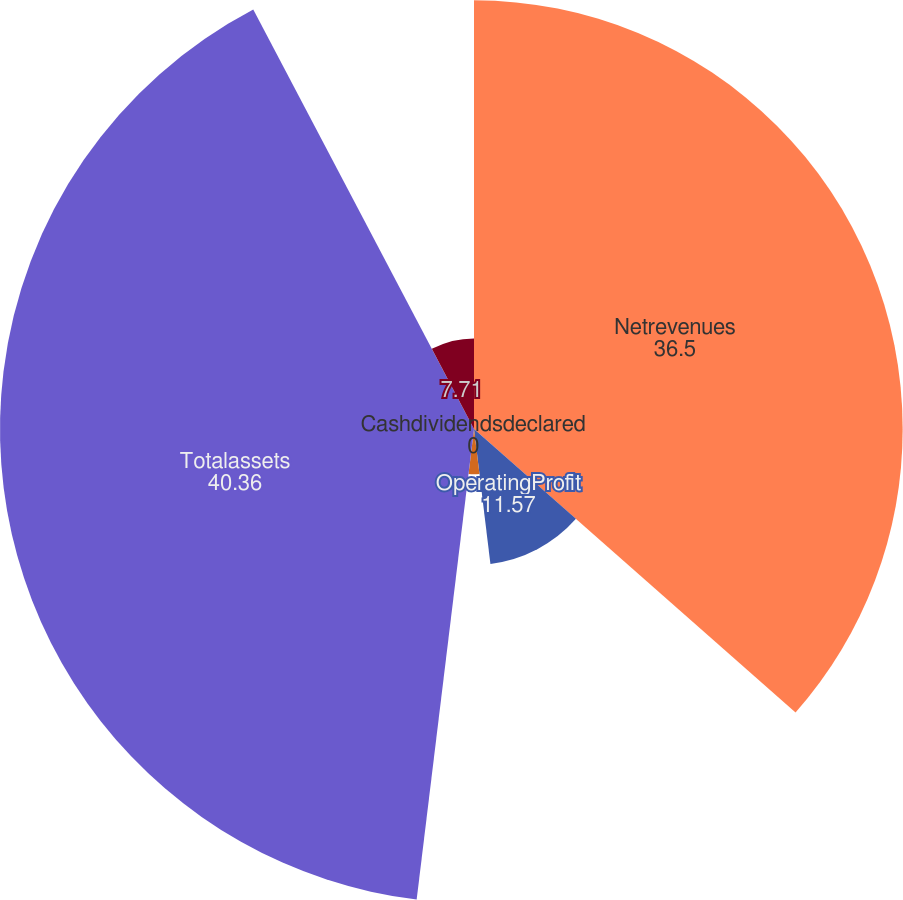Convert chart to OTSL. <chart><loc_0><loc_0><loc_500><loc_500><pie_chart><fcel>Netrevenues<fcel>OperatingProfit<fcel>Basic<fcel>Cashdividendsdeclared<fcel>Totalassets<fcel>Unnamed: 5<nl><fcel>36.5%<fcel>11.57%<fcel>3.86%<fcel>0.0%<fcel>40.36%<fcel>7.71%<nl></chart> 